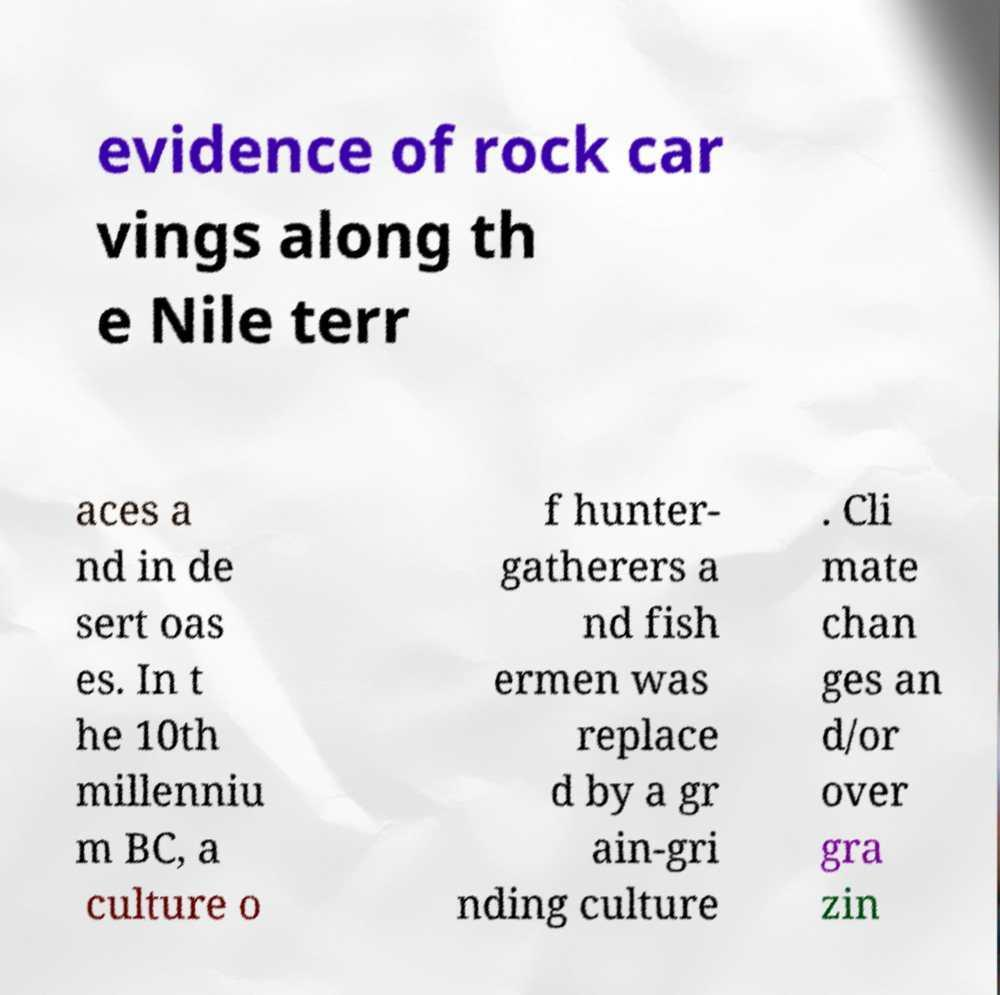What messages or text are displayed in this image? I need them in a readable, typed format. evidence of rock car vings along th e Nile terr aces a nd in de sert oas es. In t he 10th millenniu m BC, a culture o f hunter- gatherers a nd fish ermen was replace d by a gr ain-gri nding culture . Cli mate chan ges an d/or over gra zin 